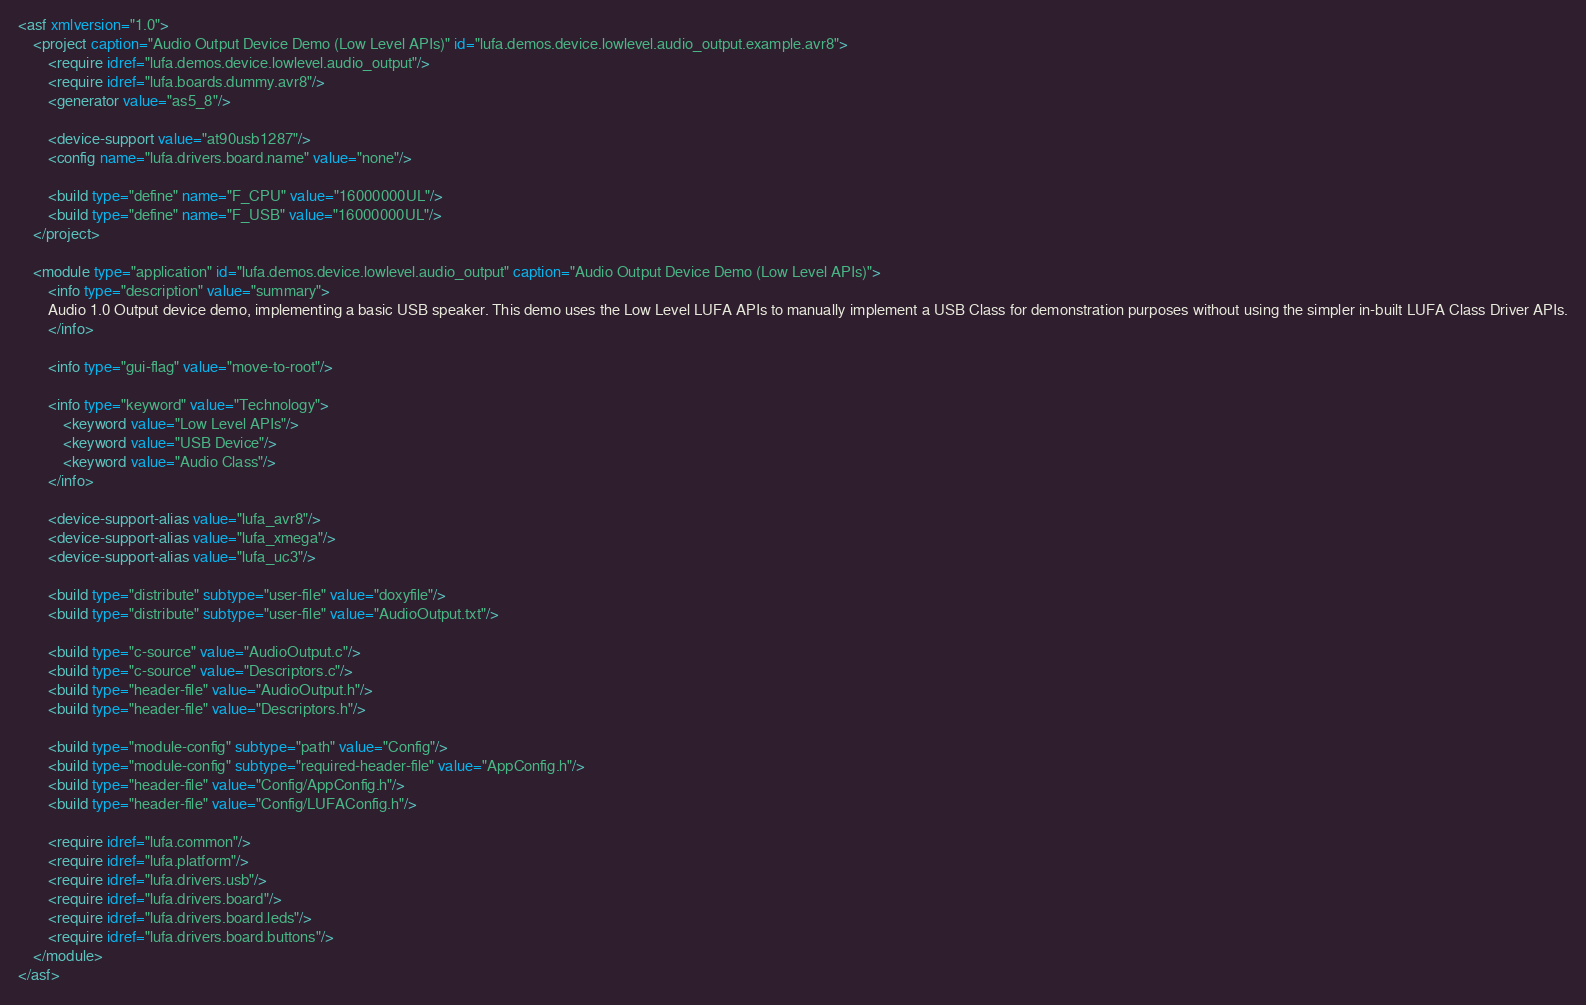Convert code to text. <code><loc_0><loc_0><loc_500><loc_500><_XML_><asf xmlversion="1.0">
	<project caption="Audio Output Device Demo (Low Level APIs)" id="lufa.demos.device.lowlevel.audio_output.example.avr8">
		<require idref="lufa.demos.device.lowlevel.audio_output"/>
		<require idref="lufa.boards.dummy.avr8"/>
		<generator value="as5_8"/>

		<device-support value="at90usb1287"/>
		<config name="lufa.drivers.board.name" value="none"/>

		<build type="define" name="F_CPU" value="16000000UL"/>
		<build type="define" name="F_USB" value="16000000UL"/>
	</project>

	<module type="application" id="lufa.demos.device.lowlevel.audio_output" caption="Audio Output Device Demo (Low Level APIs)">
		<info type="description" value="summary">
		Audio 1.0 Output device demo, implementing a basic USB speaker. This demo uses the Low Level LUFA APIs to manually implement a USB Class for demonstration purposes without using the simpler in-built LUFA Class Driver APIs.
		</info>

 		<info type="gui-flag" value="move-to-root"/>

		<info type="keyword" value="Technology">
			<keyword value="Low Level APIs"/>
			<keyword value="USB Device"/>
			<keyword value="Audio Class"/>
		</info>

		<device-support-alias value="lufa_avr8"/>
		<device-support-alias value="lufa_xmega"/>
		<device-support-alias value="lufa_uc3"/>

		<build type="distribute" subtype="user-file" value="doxyfile"/>
		<build type="distribute" subtype="user-file" value="AudioOutput.txt"/>

		<build type="c-source" value="AudioOutput.c"/>
		<build type="c-source" value="Descriptors.c"/>
		<build type="header-file" value="AudioOutput.h"/>
		<build type="header-file" value="Descriptors.h"/>

		<build type="module-config" subtype="path" value="Config"/>
		<build type="module-config" subtype="required-header-file" value="AppConfig.h"/>
		<build type="header-file" value="Config/AppConfig.h"/>
		<build type="header-file" value="Config/LUFAConfig.h"/>

		<require idref="lufa.common"/>
		<require idref="lufa.platform"/>
		<require idref="lufa.drivers.usb"/>
		<require idref="lufa.drivers.board"/>
		<require idref="lufa.drivers.board.leds"/>
		<require idref="lufa.drivers.board.buttons"/>
	</module>
</asf>
</code> 